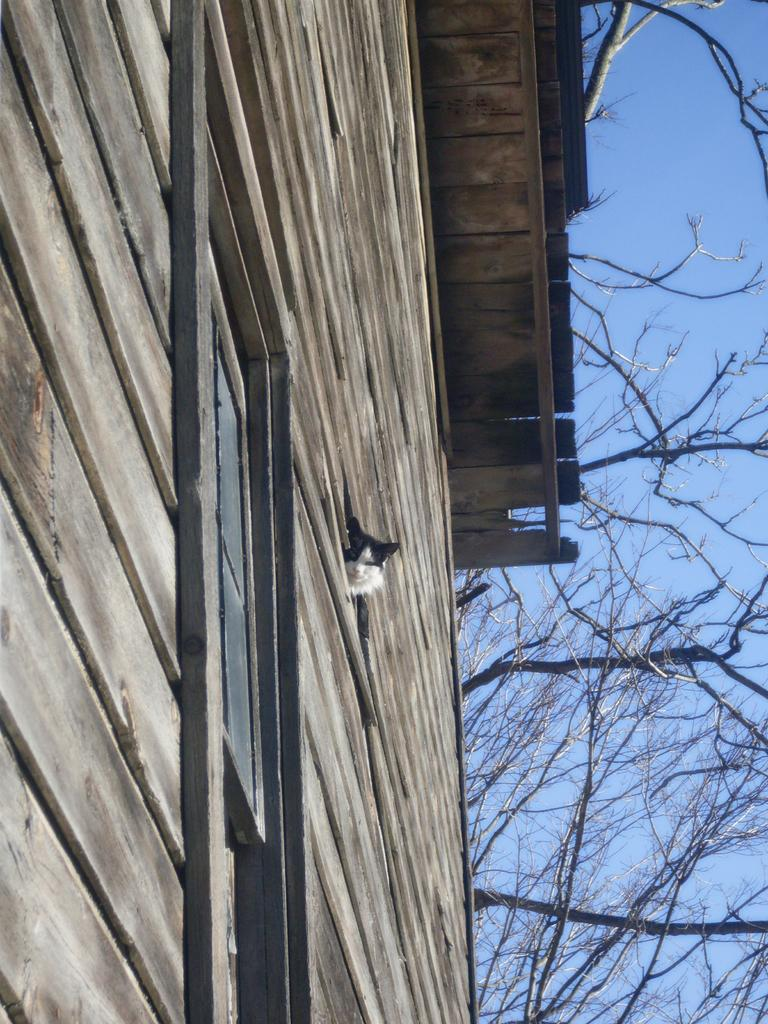What type of structure is present in the image? There is a house in the image. Where is the house located in the image? The house is towards the left side of the image. What other natural element is visible in the image? There is a tree in the image. Where is the tree located in the image? The tree is towards the right side of the image. What type of ball is being used as bait in the image? There is no ball or bait present in the image. How does the tree fall in the image? The tree does not fall in the image; it is stationary towards the right side of the image. 